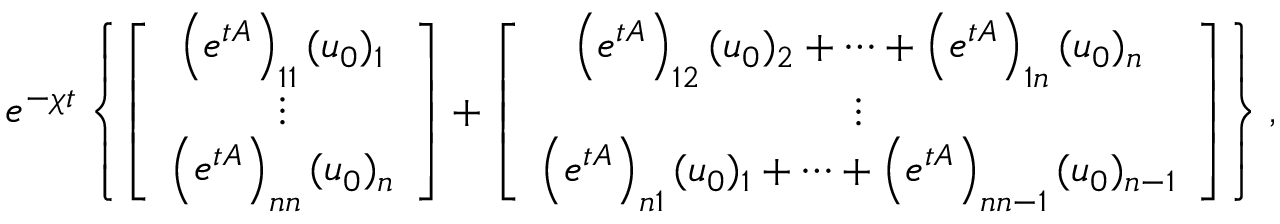Convert formula to latex. <formula><loc_0><loc_0><loc_500><loc_500>e ^ { - \chi t } \left \{ \left [ \begin{array} { c } { \left ( e ^ { t A } \right ) _ { 1 1 } ( u _ { 0 } ) _ { 1 } } \\ { \vdots } \\ { \left ( e ^ { t A } \right ) _ { n n } ( u _ { 0 } ) _ { n } } \end{array} \right ] + \left [ \begin{array} { c } { \left ( e ^ { t A } \right ) _ { 1 2 } ( u _ { 0 } ) _ { 2 } + \cdots + \left ( e ^ { t A } \right ) _ { 1 n } ( u _ { 0 } ) _ { n } } \\ { \vdots } \\ { \left ( e ^ { t A } \right ) _ { n 1 } ( u _ { 0 } ) _ { 1 } + \cdots + \left ( e ^ { t A } \right ) _ { n n - 1 } ( u _ { 0 } ) _ { n - 1 } } \end{array} \right ] \right \} ,</formula> 